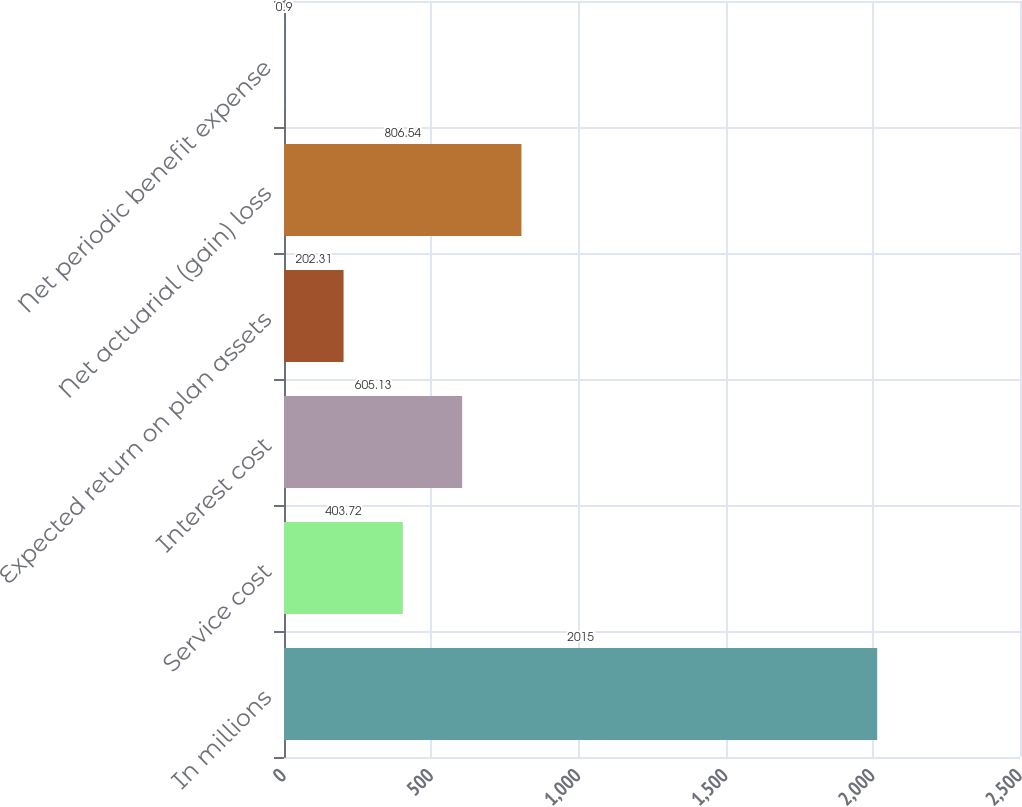Convert chart to OTSL. <chart><loc_0><loc_0><loc_500><loc_500><bar_chart><fcel>In millions<fcel>Service cost<fcel>Interest cost<fcel>Expected return on plan assets<fcel>Net actuarial (gain) loss<fcel>Net periodic benefit expense<nl><fcel>2015<fcel>403.72<fcel>605.13<fcel>202.31<fcel>806.54<fcel>0.9<nl></chart> 